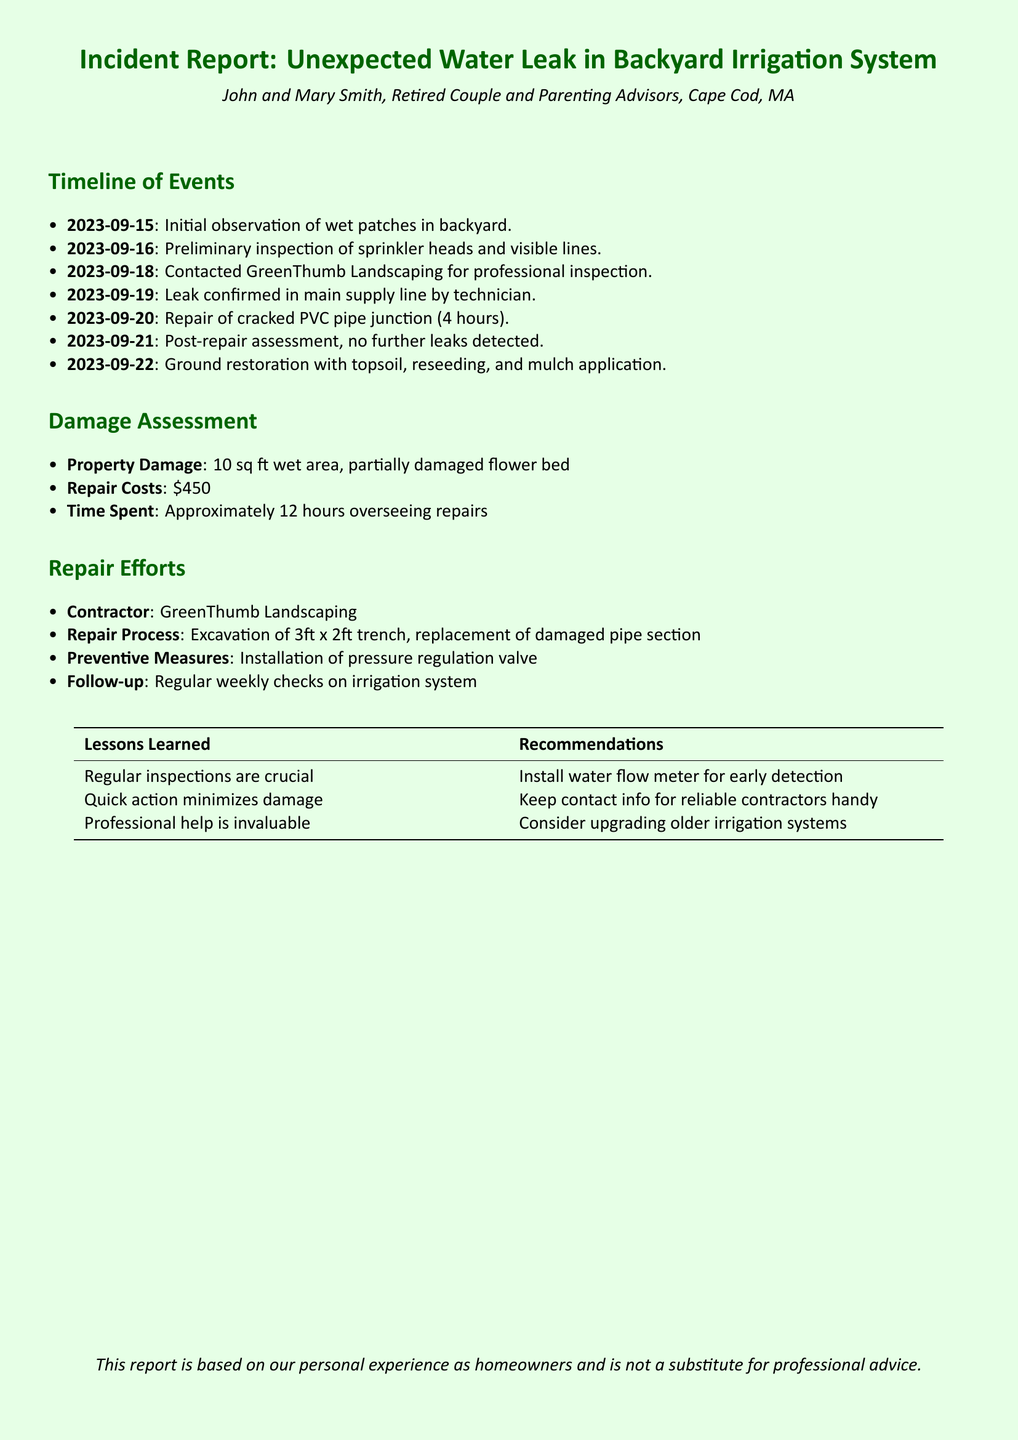What date was the leak confirmed? The leak was confirmed on 2023-09-19.
Answer: 2023-09-19 Who conducted the professional inspection? The professional inspection was conducted by GreenThumb Landscaping.
Answer: GreenThumb Landscaping How many square feet was the wet area reported? The wet area was reported to be 10 square feet.
Answer: 10 sq ft What was the total repair cost? The total repair cost was $450.
Answer: $450 What preventive measure was installed during repairs? The preventive measure installed was a pressure regulation valve.
Answer: Pressure regulation valve What was the date of the initial observation of wet patches? The initial observation of wet patches was on 2023-09-15.
Answer: 2023-09-15 How long did the repair of the cracked pipe take? The repair took 4 hours.
Answer: 4 hours What are the follow-up measures mentioned in the report? The follow-up measures mentioned are regular weekly checks on the irrigation system.
Answer: Regular weekly checks on irrigation system What lessons were learned regarding inspections? The lesson learned was that regular inspections are crucial.
Answer: Regular inspections are crucial 